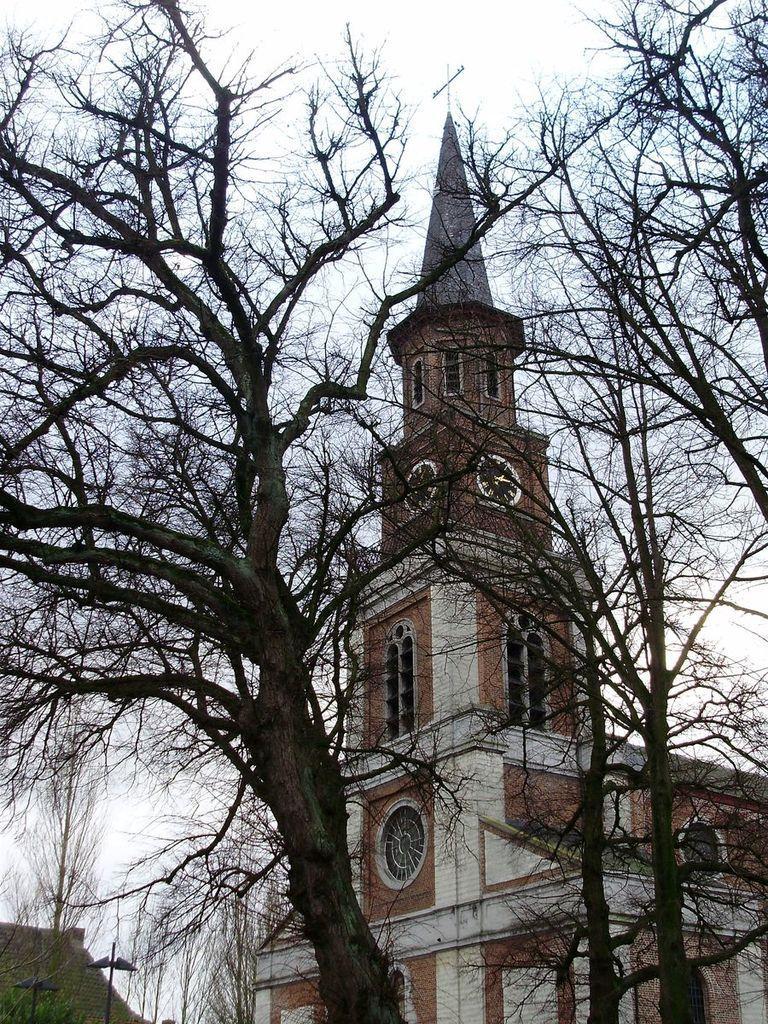Can you describe this image briefly? In this image there is a building and trees in front of that. 